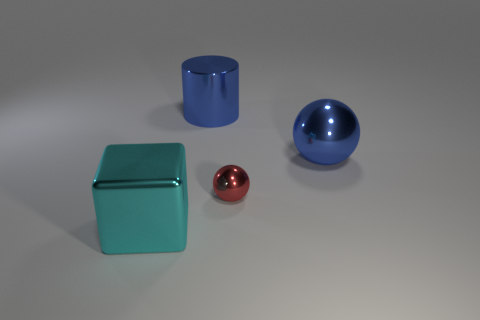Add 1 big blue metal spheres. How many objects exist? 5 Subtract all cylinders. How many objects are left? 3 Subtract 0 red cubes. How many objects are left? 4 Subtract all big gray cylinders. Subtract all big blue metallic cylinders. How many objects are left? 3 Add 4 large blue shiny objects. How many large blue shiny objects are left? 6 Add 1 small metal cylinders. How many small metal cylinders exist? 1 